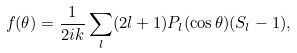Convert formula to latex. <formula><loc_0><loc_0><loc_500><loc_500>f ( \theta ) = \frac { 1 } { 2 i k } \sum _ { l } ( 2 l + 1 ) P _ { l } ( \cos \theta ) ( S _ { l } - 1 ) ,</formula> 